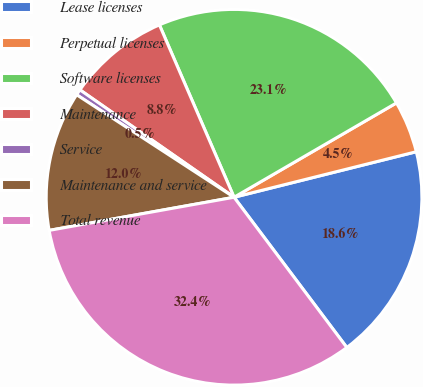<chart> <loc_0><loc_0><loc_500><loc_500><pie_chart><fcel>Lease licenses<fcel>Perpetual licenses<fcel>Software licenses<fcel>Maintenance<fcel>Service<fcel>Maintenance and service<fcel>Total revenue<nl><fcel>18.65%<fcel>4.48%<fcel>23.13%<fcel>8.81%<fcel>0.5%<fcel>12.01%<fcel>32.43%<nl></chart> 